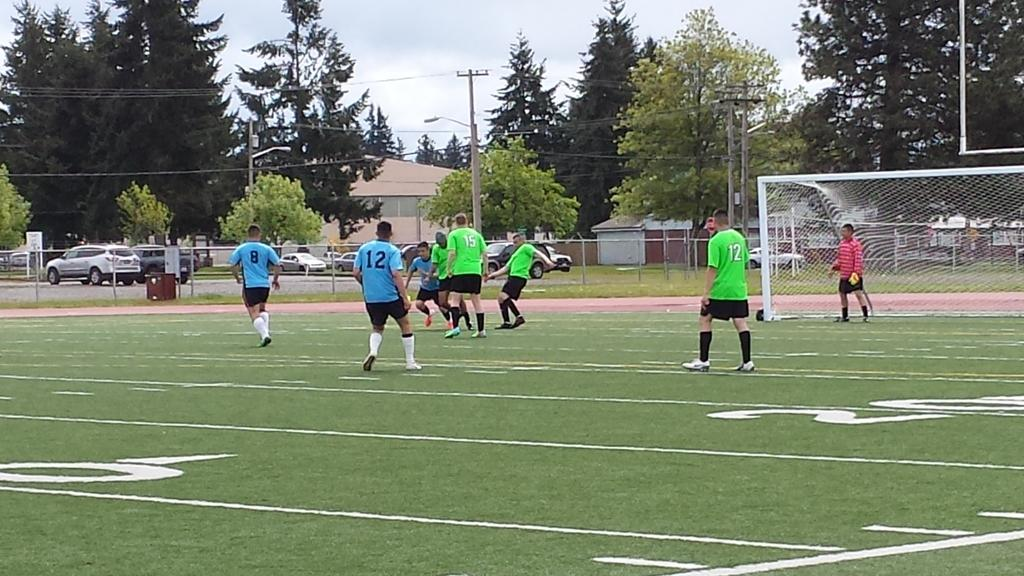<image>
Describe the image concisely. a football field with the number 20 on it 